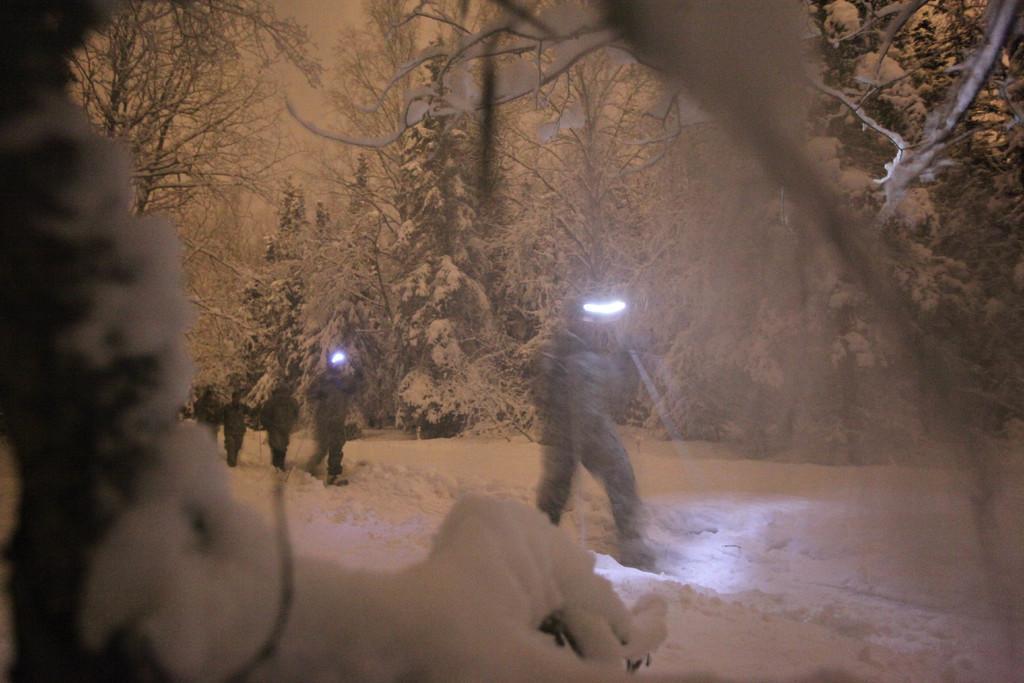Describe this image in one or two sentences. In this image I can see the snow on the land. There are few people walking on the snow by holding torch lights in their hands. In the background, I can see some trees which are covered with the snow. 